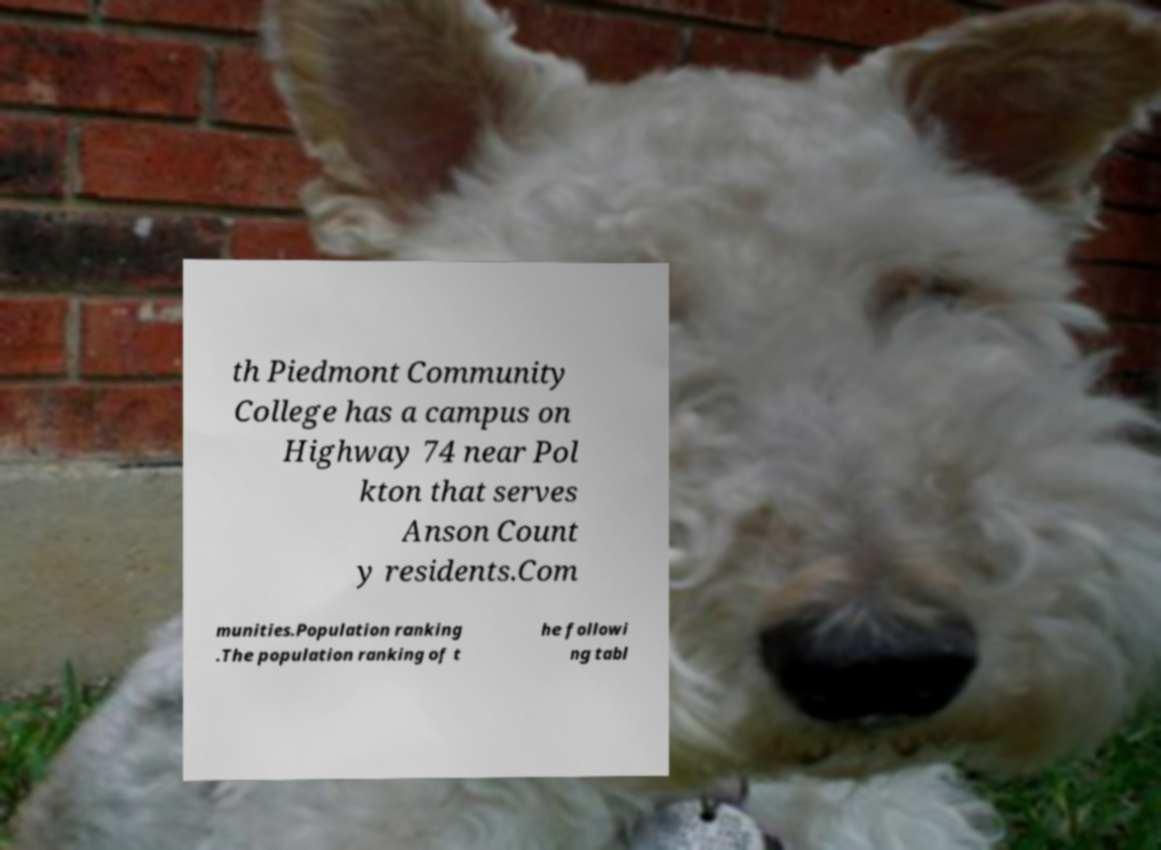Could you assist in decoding the text presented in this image and type it out clearly? th Piedmont Community College has a campus on Highway 74 near Pol kton that serves Anson Count y residents.Com munities.Population ranking .The population ranking of t he followi ng tabl 